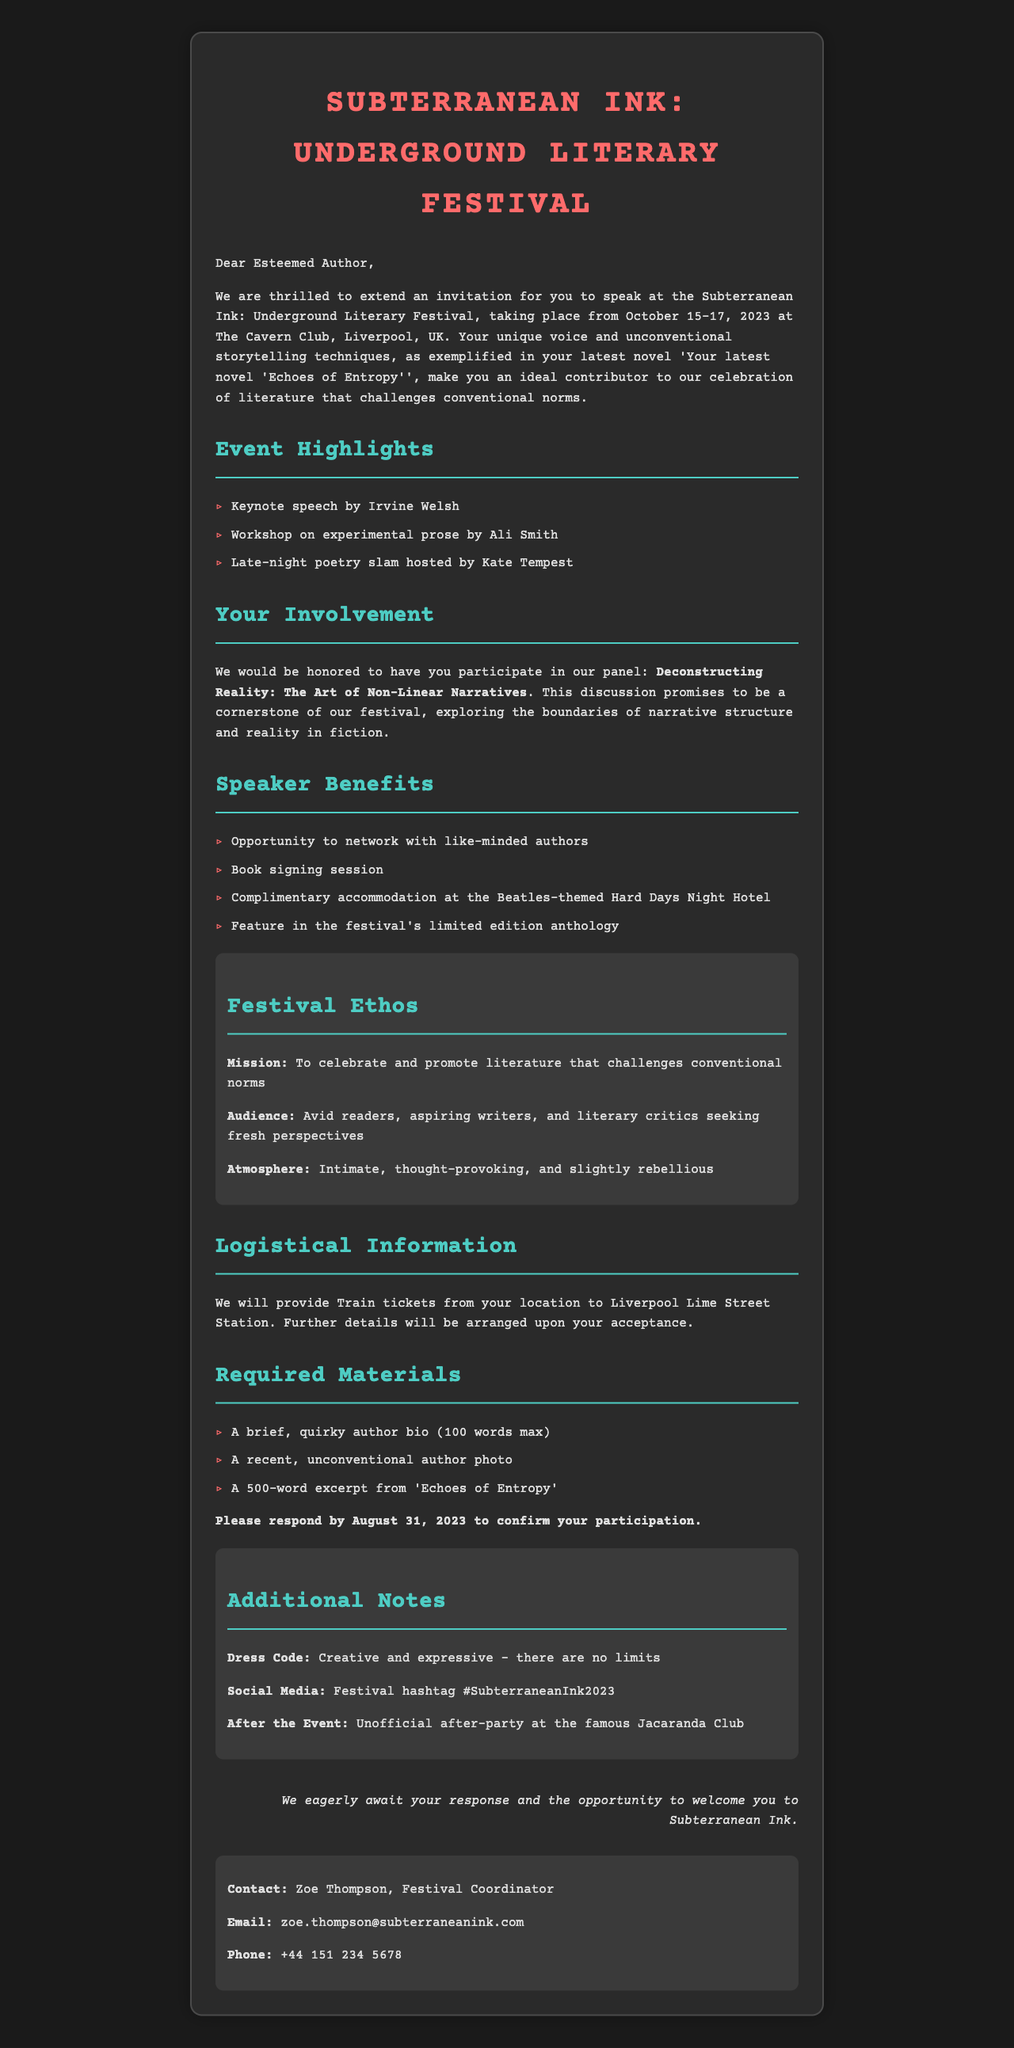What are the festival dates? The festival takes place over the specified dates in the document which is October 15-17, 2023.
Answer: October 15-17, 2023 Who is the organizer of the festival? The organizer is mentioned in the document as the Renegade Writers Collective.
Answer: Renegade Writers Collective What is the panel topic? The document specifies the panel topic as "Deconstructing Reality: The Art of Non-Linear Narratives".
Answer: Deconstructing Reality: The Art of Non-Linear Narratives What benefits are offered to speakers? The document lists several benefits for speakers, including a book signing session among others.
Answer: Opportunity to network with like-minded authors What is the required submission material for the invitation? The document mentions specific requested materials such as a brief author bio, headshot, and book excerpt.
Answer: A brief, quirky author bio What is the dress code for the festival? The document specifies a creative and expressive dress code with no limits.
Answer: Creative and expressive Who is the contact person for logistical information? The document provides the name of the contact person for logistical details, which is Zoe Thompson.
Answer: Zoe Thompson What is the festival's mission? The mission is stated in the document as celebrating and promoting literature that challenges conventional norms.
Answer: To celebrate and promote literature that challenges conventional norms What is the post-event plan mentioned? The document notes an unofficial after-party at the Jacaranda Club after the event.
Answer: Unofficial after-party at the famous Jacaranda Club 